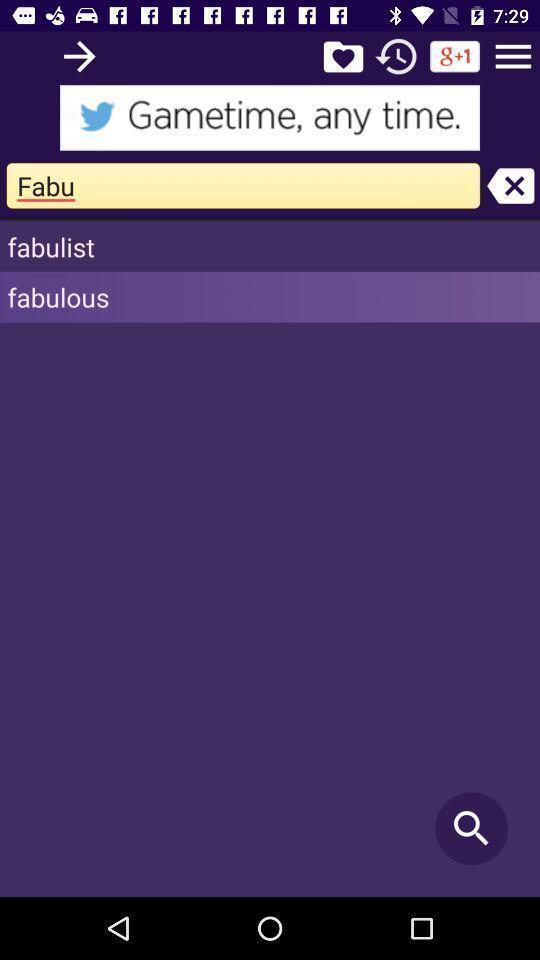Explain what's happening in this screen capture. Searching for a word. 